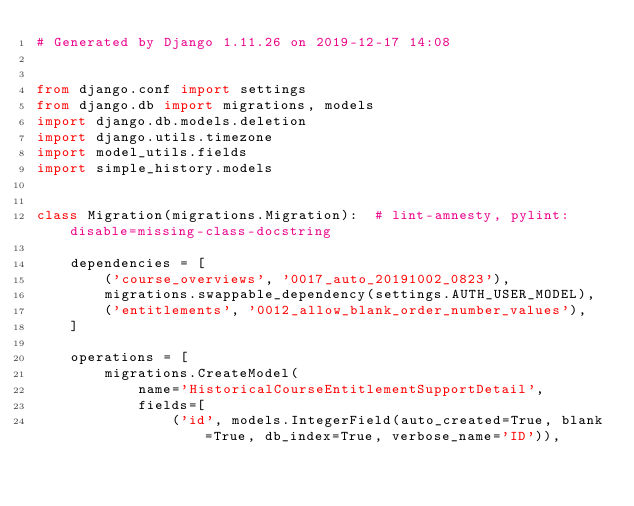<code> <loc_0><loc_0><loc_500><loc_500><_Python_># Generated by Django 1.11.26 on 2019-12-17 14:08


from django.conf import settings
from django.db import migrations, models
import django.db.models.deletion
import django.utils.timezone
import model_utils.fields
import simple_history.models


class Migration(migrations.Migration):  # lint-amnesty, pylint: disable=missing-class-docstring

    dependencies = [
        ('course_overviews', '0017_auto_20191002_0823'),
        migrations.swappable_dependency(settings.AUTH_USER_MODEL),
        ('entitlements', '0012_allow_blank_order_number_values'),
    ]

    operations = [
        migrations.CreateModel(
            name='HistoricalCourseEntitlementSupportDetail',
            fields=[
                ('id', models.IntegerField(auto_created=True, blank=True, db_index=True, verbose_name='ID')),</code> 